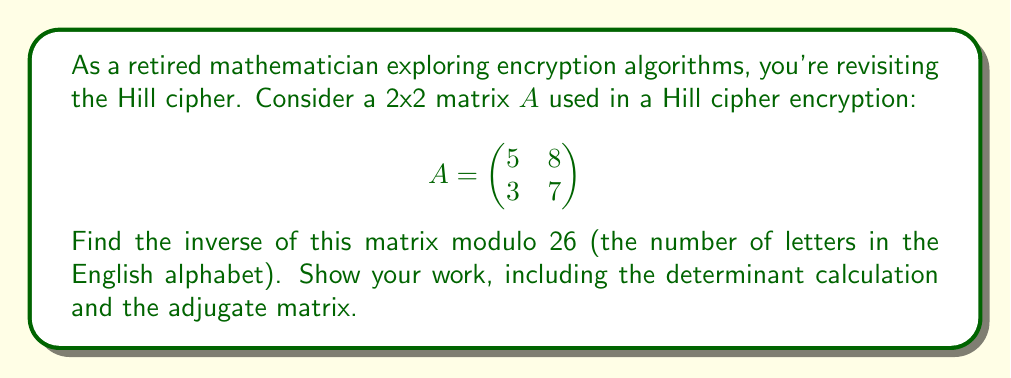Teach me how to tackle this problem. To find the inverse of matrix $A$ modulo 26, we'll follow these steps:

1) Calculate the determinant:
   $det(A) = 5 \cdot 7 - 8 \cdot 3 = 35 - 24 = 11$

2) Find the modular multiplicative inverse of $det(A)$ modulo 26:
   We need to find $d$ such that $11d \equiv 1 \pmod{26}$
   By trying values, we find that $d = 19$ works, as $11 \cdot 19 = 209 \equiv 1 \pmod{26}$

3) Calculate the adjugate matrix:
   $$adj(A) = \begin{pmatrix}
   7 & -8 \\
   -3 & 5
   \end{pmatrix}$$

4) Multiply the adjugate by $d$ and take modulo 26:
   $$19 \cdot \begin{pmatrix}
   7 & -8 \\
   -3 & 5
   \end{pmatrix} \equiv \begin{pmatrix}
   133 & -152 \\
   -57 & 95
   \end{pmatrix} \pmod{26}$$

5) Simplify each element modulo 26:
   $$\begin{pmatrix}
   133 \bmod 26 & -152 \bmod 26 \\
   -57 \bmod 26 & 95 \bmod 26
   \end{pmatrix} = \begin{pmatrix}
   3 & 4 \\
   21 & 17
   \end{pmatrix}$$

Therefore, the inverse of $A$ modulo 26 is:
$$A^{-1} \equiv \begin{pmatrix}
3 & 4 \\
21 & 17
\end{pmatrix} \pmod{26}$$
Answer: $$A^{-1} \equiv \begin{pmatrix}
3 & 4 \\
21 & 17
\end{pmatrix} \pmod{26}$$ 